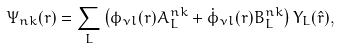<formula> <loc_0><loc_0><loc_500><loc_500>\Psi _ { n { k } } ( { r } ) = \sum _ { L } \left ( \phi _ { \nu l } ( r ) A _ { L } ^ { n { k } } + \dot { \phi } _ { \nu l } ( r ) B _ { L } ^ { n { k } } \right ) Y _ { L } ( \hat { r } ) ,</formula> 